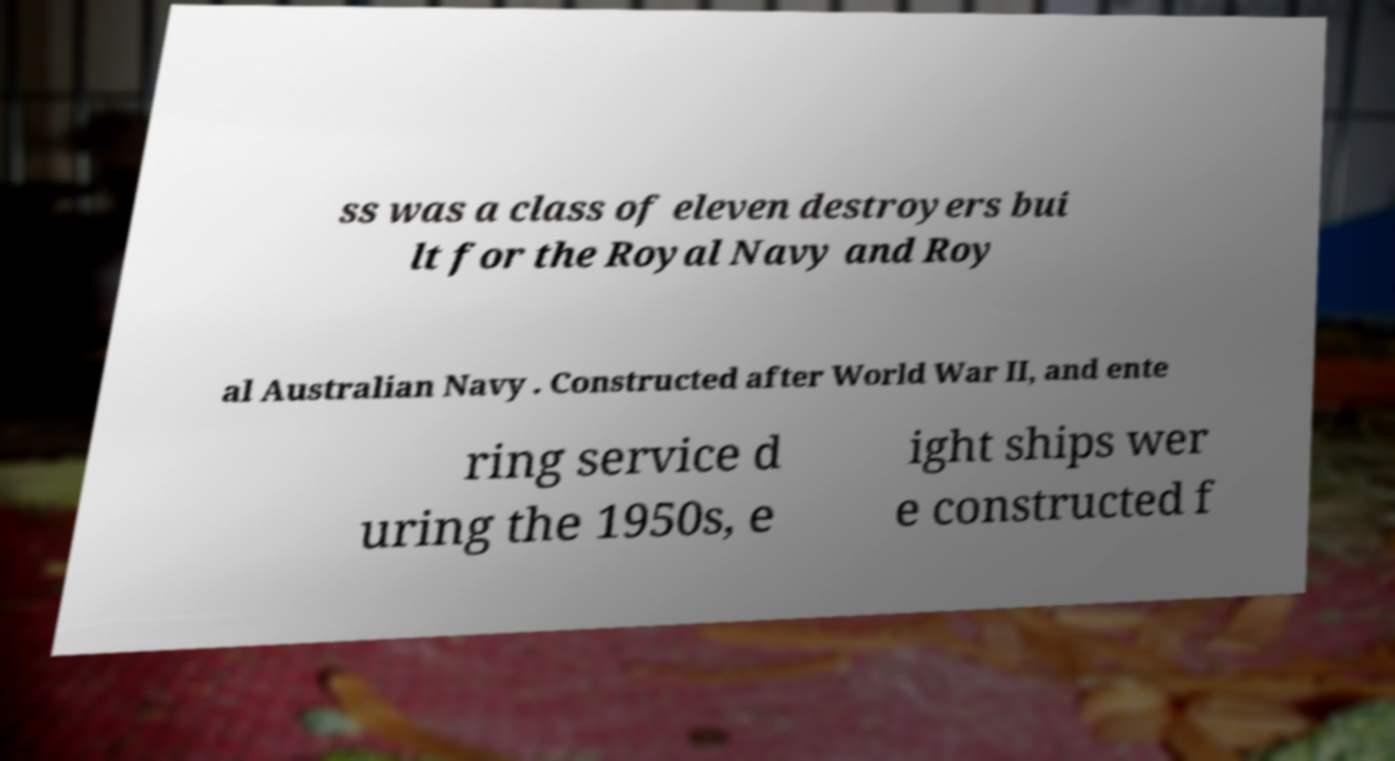Could you assist in decoding the text presented in this image and type it out clearly? ss was a class of eleven destroyers bui lt for the Royal Navy and Roy al Australian Navy . Constructed after World War II, and ente ring service d uring the 1950s, e ight ships wer e constructed f 